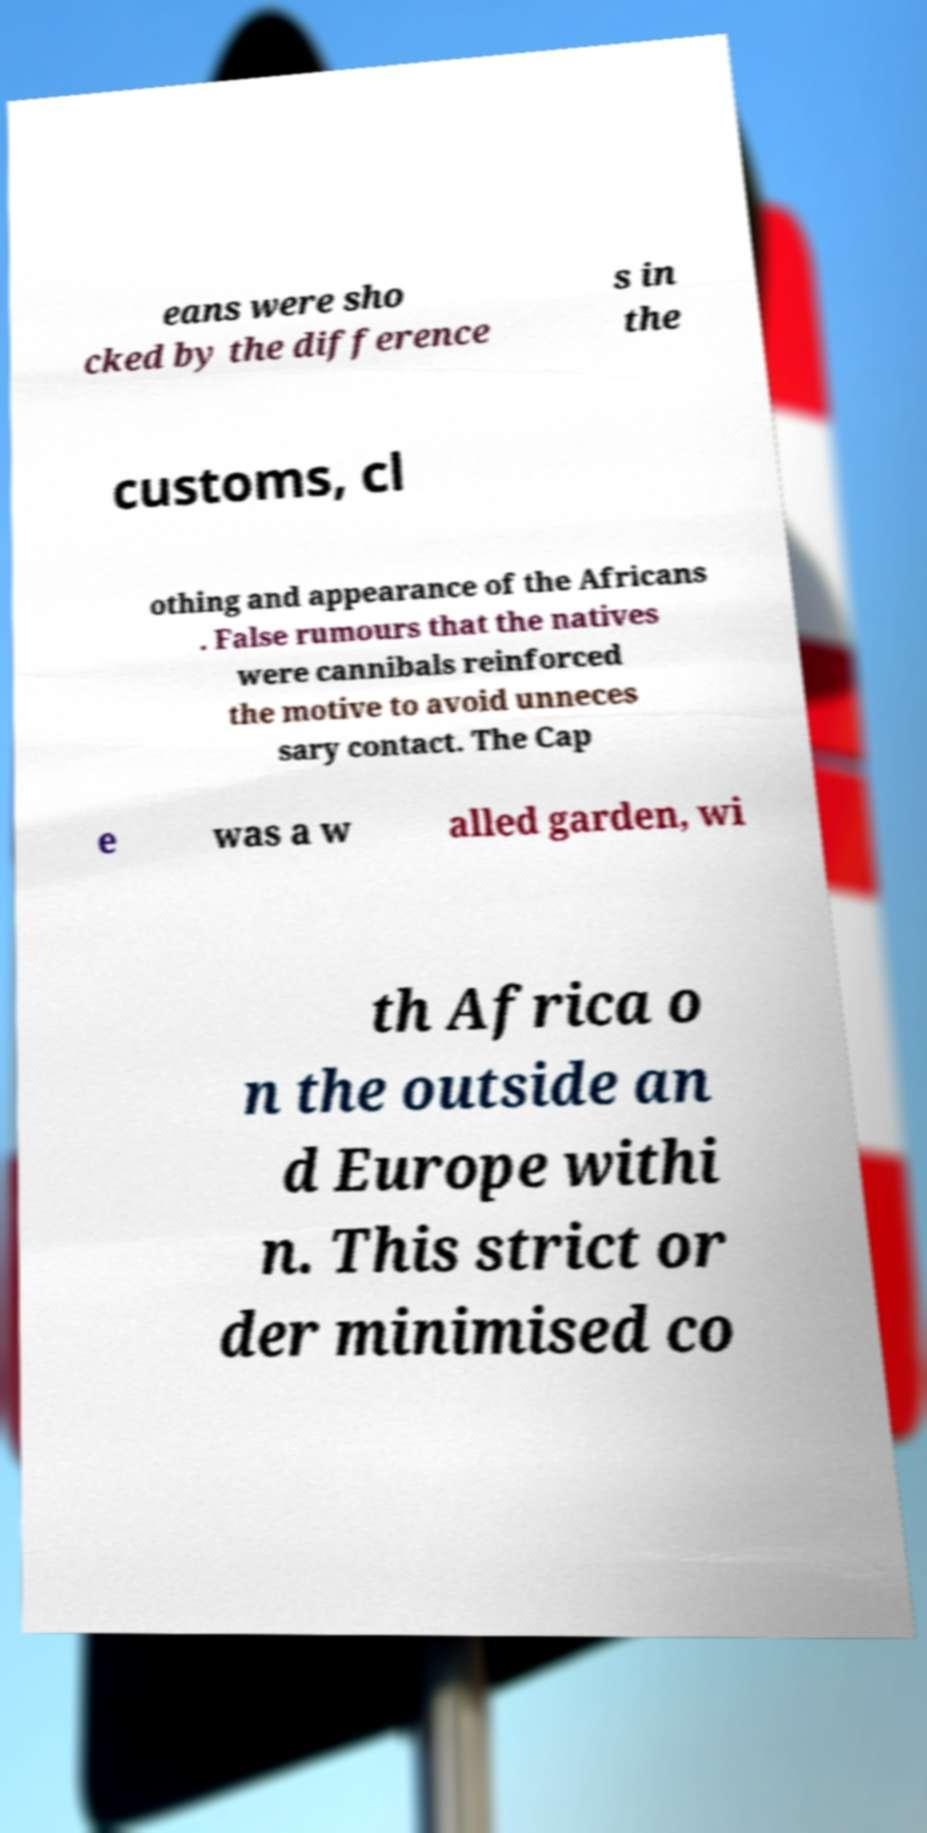Could you extract and type out the text from this image? eans were sho cked by the difference s in the customs, cl othing and appearance of the Africans . False rumours that the natives were cannibals reinforced the motive to avoid unneces sary contact. The Cap e was a w alled garden, wi th Africa o n the outside an d Europe withi n. This strict or der minimised co 